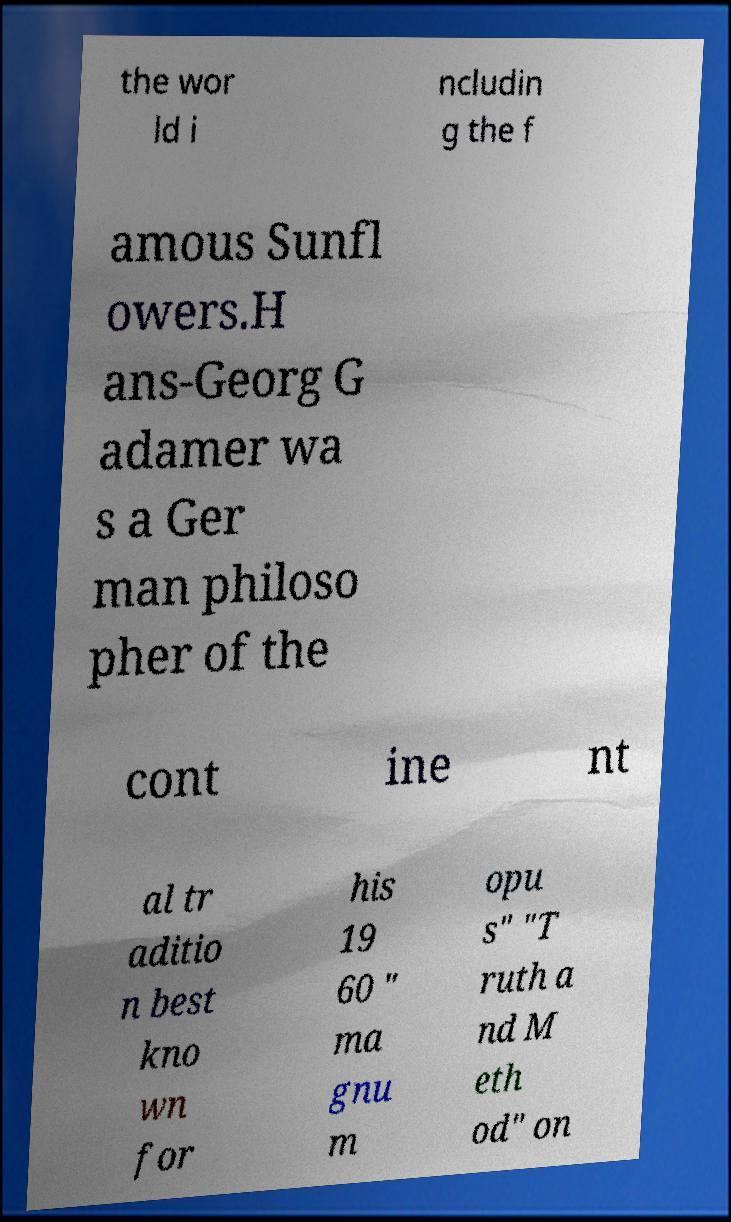Could you extract and type out the text from this image? the wor ld i ncludin g the f amous Sunfl owers.H ans-Georg G adamer wa s a Ger man philoso pher of the cont ine nt al tr aditio n best kno wn for his 19 60 " ma gnu m opu s" "T ruth a nd M eth od" on 